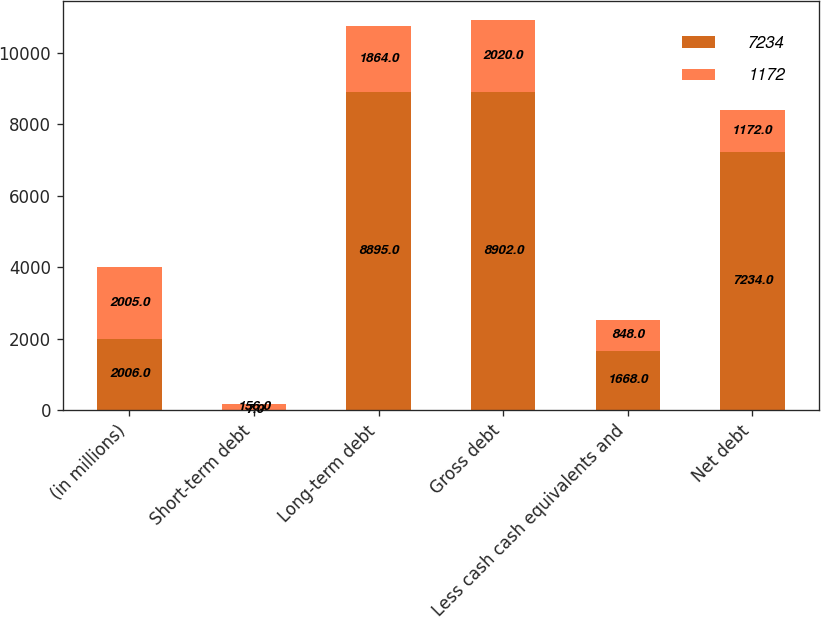Convert chart. <chart><loc_0><loc_0><loc_500><loc_500><stacked_bar_chart><ecel><fcel>(in millions)<fcel>Short-term debt<fcel>Long-term debt<fcel>Gross debt<fcel>Less cash cash equivalents and<fcel>Net debt<nl><fcel>7234<fcel>2006<fcel>7<fcel>8895<fcel>8902<fcel>1668<fcel>7234<nl><fcel>1172<fcel>2005<fcel>156<fcel>1864<fcel>2020<fcel>848<fcel>1172<nl></chart> 